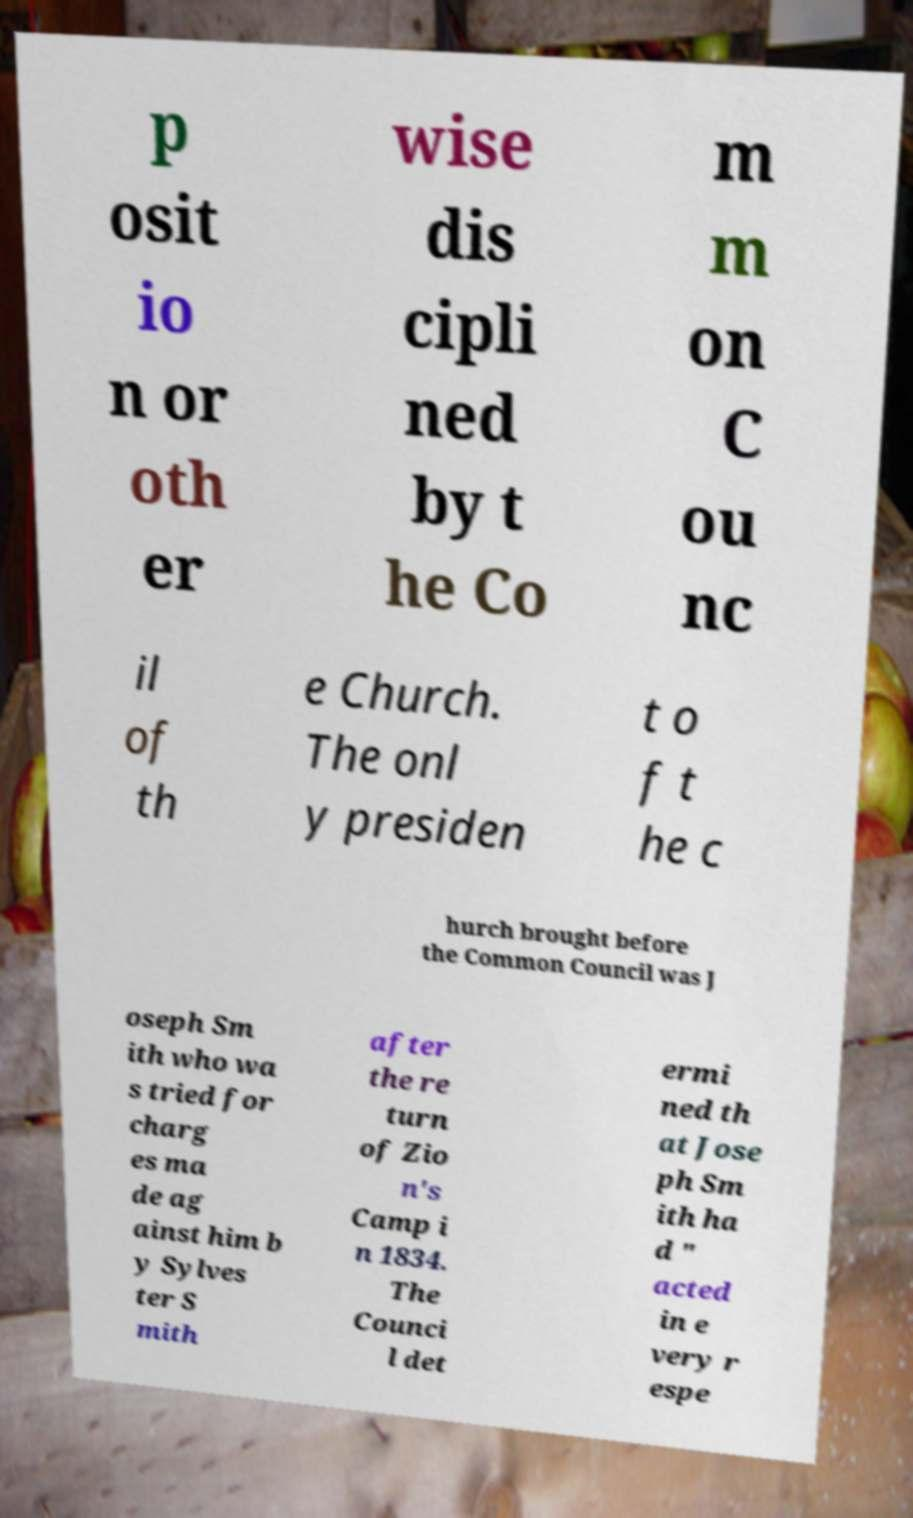I need the written content from this picture converted into text. Can you do that? p osit io n or oth er wise dis cipli ned by t he Co m m on C ou nc il of th e Church. The onl y presiden t o f t he c hurch brought before the Common Council was J oseph Sm ith who wa s tried for charg es ma de ag ainst him b y Sylves ter S mith after the re turn of Zio n's Camp i n 1834. The Counci l det ermi ned th at Jose ph Sm ith ha d " acted in e very r espe 